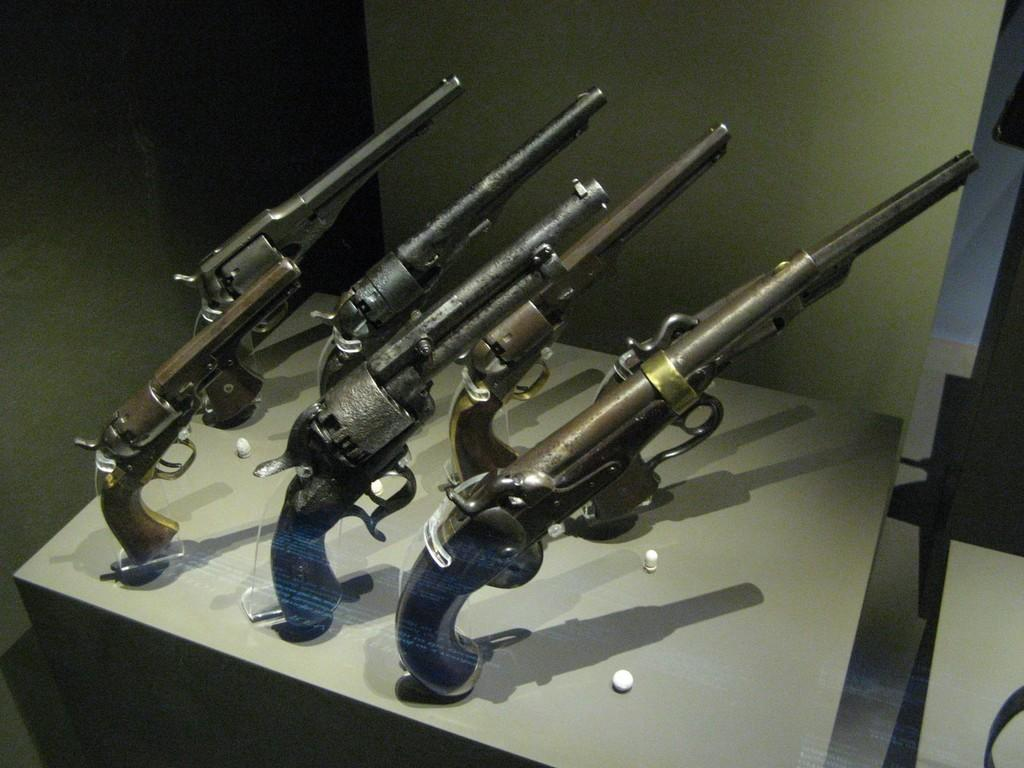What type of weapons are in the image? There are rifles in the image. Where are the rifles located? The rifles are on an object. What organization is responsible for the account of the rifles in the image? There is no information about an organization or account related to the rifles in the image. 